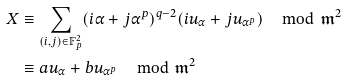<formula> <loc_0><loc_0><loc_500><loc_500>X & \equiv \sum _ { ( i , j ) \in \mathbb { F } _ { p } ^ { 2 } } ( i \alpha + j \alpha ^ { p } ) ^ { q - 2 } ( i u _ { \alpha } + j u _ { \alpha ^ { p } } ) \, \mod \mathfrak { m } ^ { 2 } \\ & \equiv a u _ { \alpha } + b u _ { \alpha ^ { p } } \, \mod \mathfrak { m } ^ { 2 }</formula> 